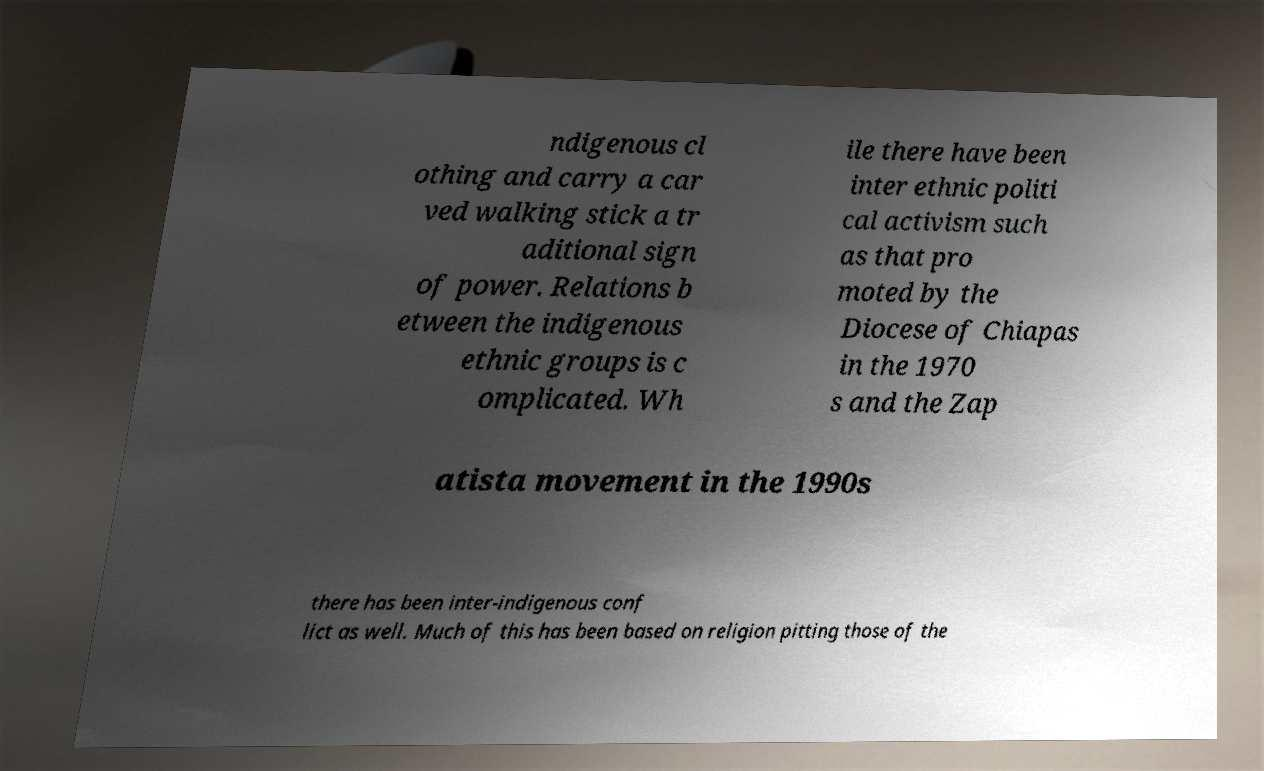Please read and relay the text visible in this image. What does it say? ndigenous cl othing and carry a car ved walking stick a tr aditional sign of power. Relations b etween the indigenous ethnic groups is c omplicated. Wh ile there have been inter ethnic politi cal activism such as that pro moted by the Diocese of Chiapas in the 1970 s and the Zap atista movement in the 1990s there has been inter-indigenous conf lict as well. Much of this has been based on religion pitting those of the 